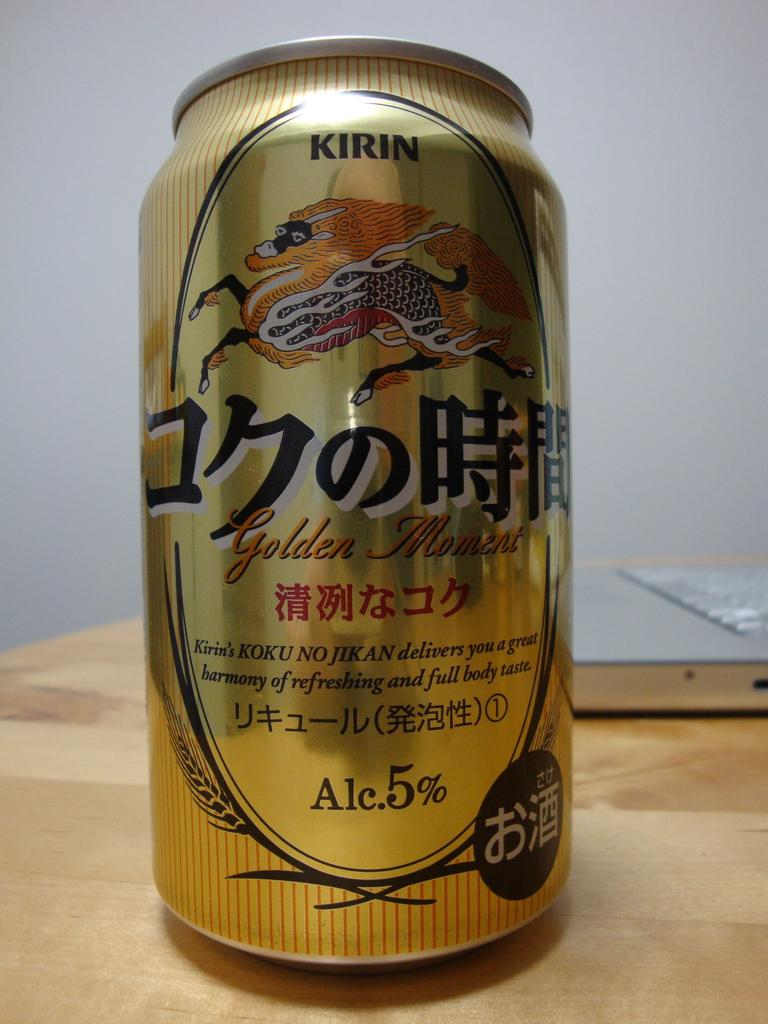<image>
Create a compact narrative representing the image presented. Gold and black can that says the word Golden Moment. 